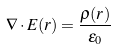<formula> <loc_0><loc_0><loc_500><loc_500>\nabla \cdot E ( r ) = \frac { \rho ( r ) } { \epsilon _ { 0 } }</formula> 